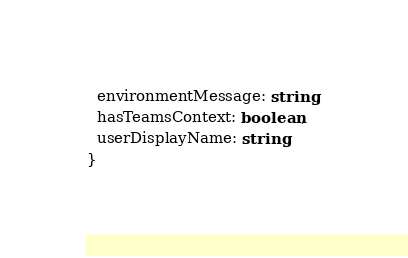<code> <loc_0><loc_0><loc_500><loc_500><_TypeScript_>  environmentMessage: string;
  hasTeamsContext: boolean;
  userDisplayName: string;
}
</code> 